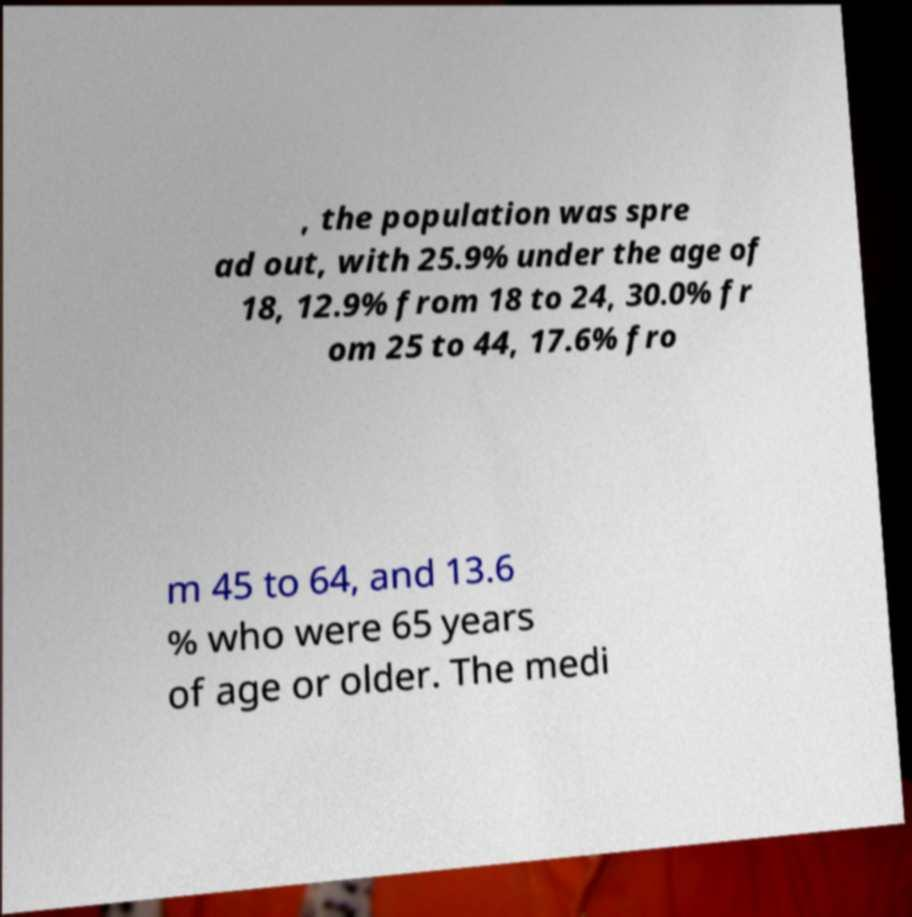Could you assist in decoding the text presented in this image and type it out clearly? , the population was spre ad out, with 25.9% under the age of 18, 12.9% from 18 to 24, 30.0% fr om 25 to 44, 17.6% fro m 45 to 64, and 13.6 % who were 65 years of age or older. The medi 